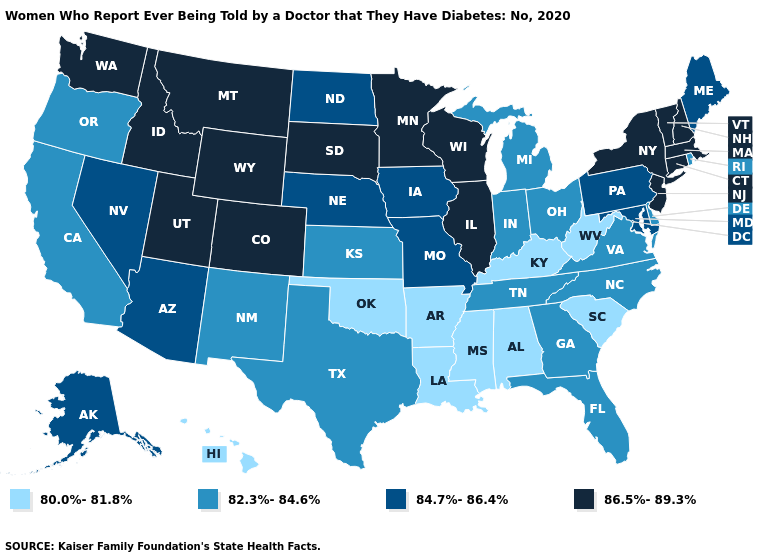Does Iowa have the same value as Nebraska?
Quick response, please. Yes. Does Montana have a higher value than Massachusetts?
Give a very brief answer. No. What is the value of Alabama?
Be succinct. 80.0%-81.8%. What is the value of Colorado?
Quick response, please. 86.5%-89.3%. Name the states that have a value in the range 82.3%-84.6%?
Short answer required. California, Delaware, Florida, Georgia, Indiana, Kansas, Michigan, New Mexico, North Carolina, Ohio, Oregon, Rhode Island, Tennessee, Texas, Virginia. Does Hawaii have the lowest value in the USA?
Concise answer only. Yes. Name the states that have a value in the range 82.3%-84.6%?
Be succinct. California, Delaware, Florida, Georgia, Indiana, Kansas, Michigan, New Mexico, North Carolina, Ohio, Oregon, Rhode Island, Tennessee, Texas, Virginia. Does Minnesota have the highest value in the MidWest?
Be succinct. Yes. How many symbols are there in the legend?
Keep it brief. 4. Among the states that border Michigan , does Wisconsin have the highest value?
Give a very brief answer. Yes. Among the states that border Georgia , which have the lowest value?
Short answer required. Alabama, South Carolina. What is the value of Indiana?
Write a very short answer. 82.3%-84.6%. Does Utah have the same value as Kansas?
Quick response, please. No. How many symbols are there in the legend?
Concise answer only. 4. Name the states that have a value in the range 80.0%-81.8%?
Short answer required. Alabama, Arkansas, Hawaii, Kentucky, Louisiana, Mississippi, Oklahoma, South Carolina, West Virginia. 